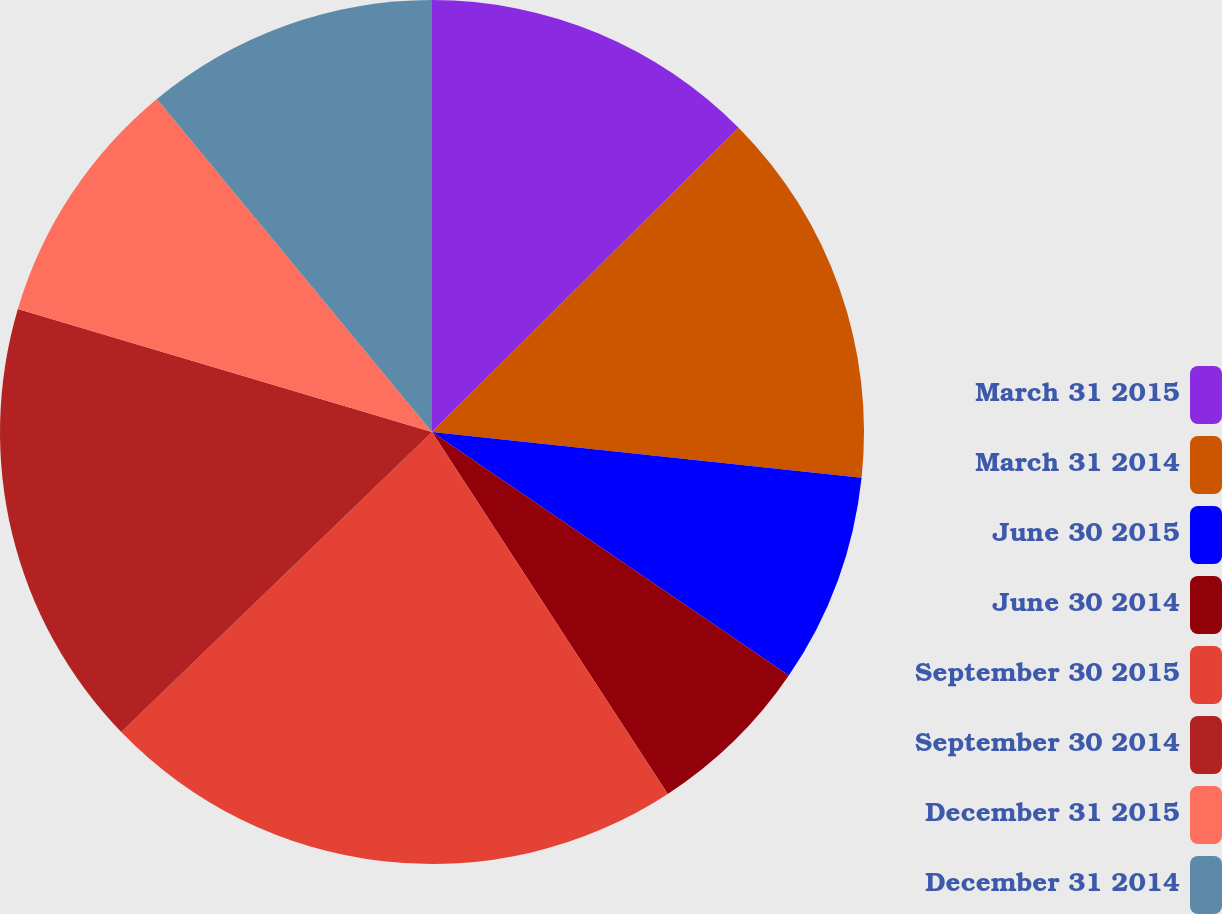Convert chart. <chart><loc_0><loc_0><loc_500><loc_500><pie_chart><fcel>March 31 2015<fcel>March 31 2014<fcel>June 30 2015<fcel>June 30 2014<fcel>September 30 2015<fcel>September 30 2014<fcel>December 31 2015<fcel>December 31 2014<nl><fcel>12.56%<fcel>14.13%<fcel>7.85%<fcel>6.28%<fcel>21.97%<fcel>16.82%<fcel>9.42%<fcel>10.99%<nl></chart> 